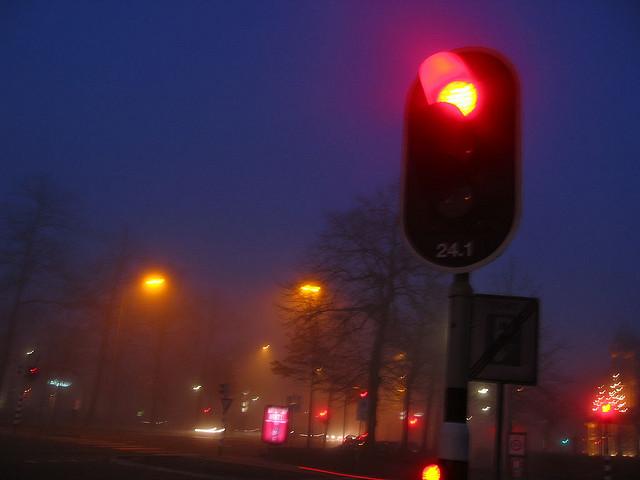What color is the traffic light?
Give a very brief answer. Red. Are there street lights on?
Give a very brief answer. Yes. How many lights are next to the stop sign?
Concise answer only. 1. Should cars at this light stop or go?
Give a very brief answer. Stop. When it is on do you have to stop?
Short answer required. Yes. 